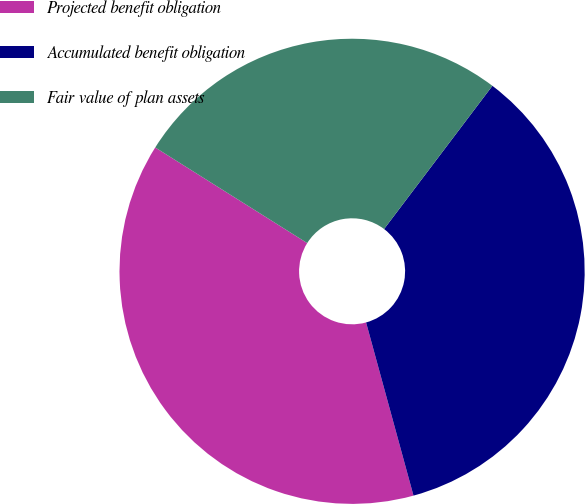Convert chart. <chart><loc_0><loc_0><loc_500><loc_500><pie_chart><fcel>Projected benefit obligation<fcel>Accumulated benefit obligation<fcel>Fair value of plan assets<nl><fcel>38.19%<fcel>35.44%<fcel>26.37%<nl></chart> 